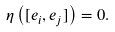<formula> <loc_0><loc_0><loc_500><loc_500>\eta \left ( [ e _ { i } , e _ { j } ] \right ) = 0 .</formula> 